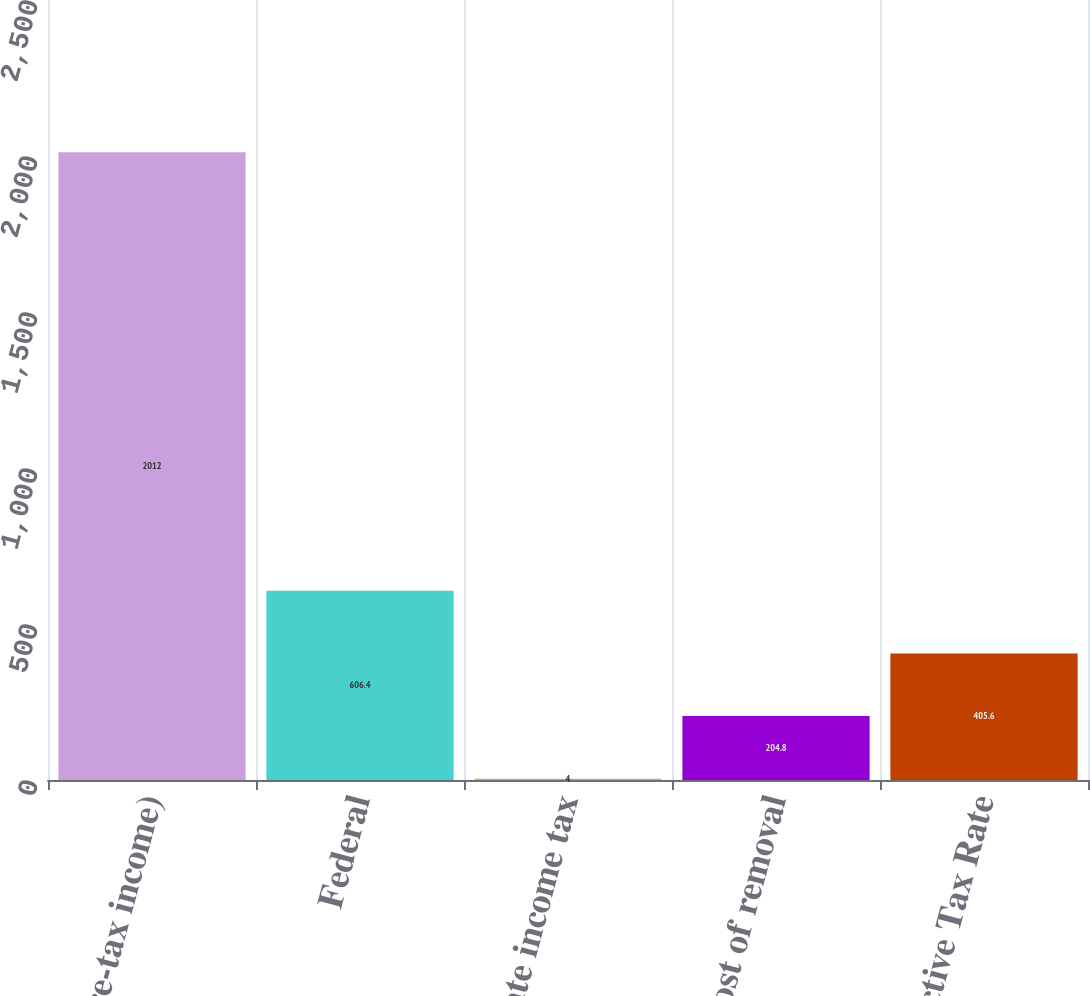Convert chart. <chart><loc_0><loc_0><loc_500><loc_500><bar_chart><fcel>( of Pre-tax income)<fcel>Federal<fcel>State income tax<fcel>Cost of removal<fcel>Effective Tax Rate<nl><fcel>2012<fcel>606.4<fcel>4<fcel>204.8<fcel>405.6<nl></chart> 